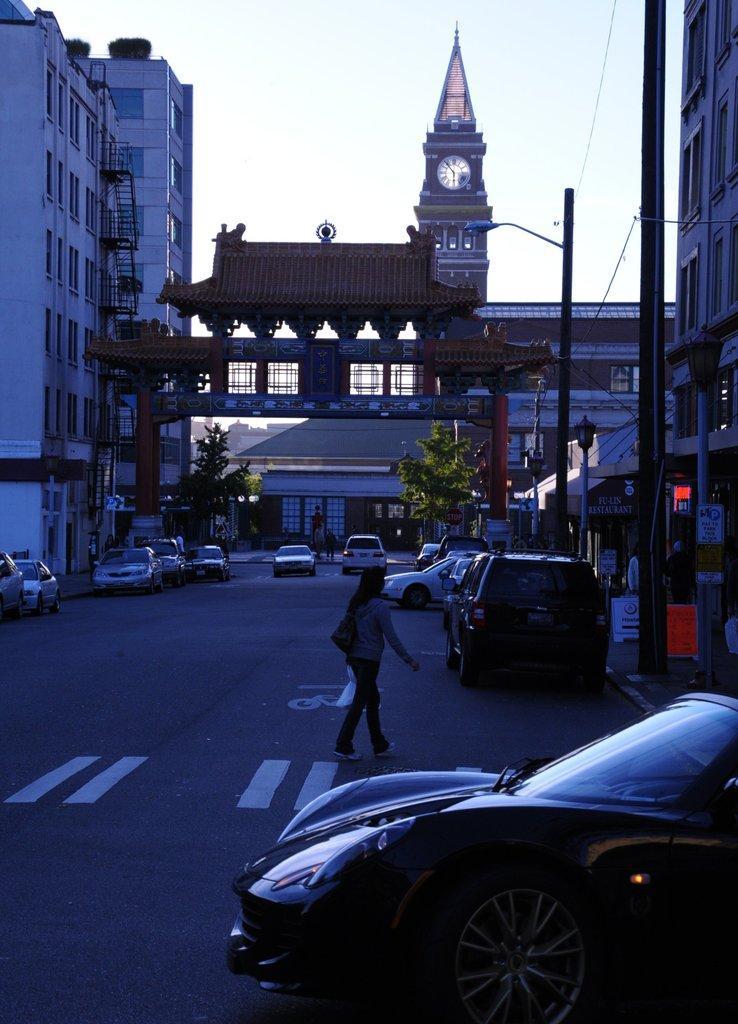In one or two sentences, can you explain what this image depicts? In this image on a road there are few vehicles. Here a person is walking. In the background there are buildings, trees, electric poles, street lights. This is a clock tower. 